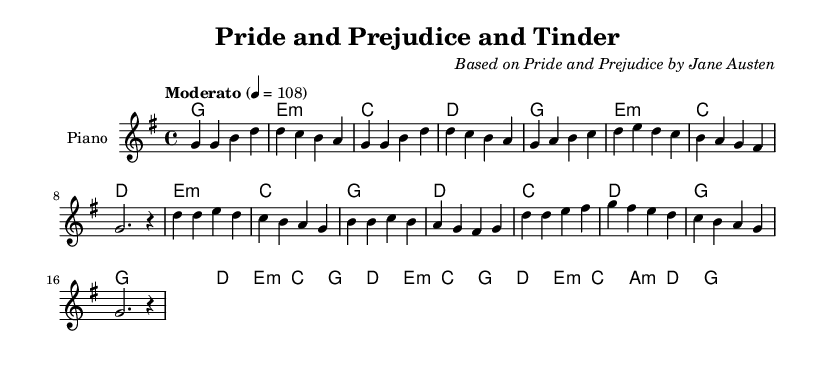What is the key signature of this music? The key signature is indicated as one sharp in the notation, which corresponds to G major.
Answer: G major What is the time signature of the piece? The time signature is represented at the beginning of the score; it is shown as 4/4, meaning there are four beats per measure.
Answer: 4/4 What is the tempo marking of the piece? The tempo is expressed using a text indication that suggests the speed of the music; here, it is marked as "Moderato," which translates to moderate speed.
Answer: Moderato How many measures are in the verse section? By counting the number of measure lines in the melody section labeled as the "Verse," there are a total of eight measures present.
Answer: Eight What is the structure of the song based on the sections presented? The music is divided into two main sections: a Verse and a Chorus, as indicated within the melodies and separate labels.
Answer: Verse and Chorus Which classical novel is referenced in the title? The title explicitly includes a reference to "Pride and Prejudice," indicating the classic novel that inspired the song.
Answer: Pride and Prejudice What instrument is designated for the score? The score specifies that the music should be played on a "Piano," as indicated in the instrument notation at the beginning of the staff.
Answer: Piano 